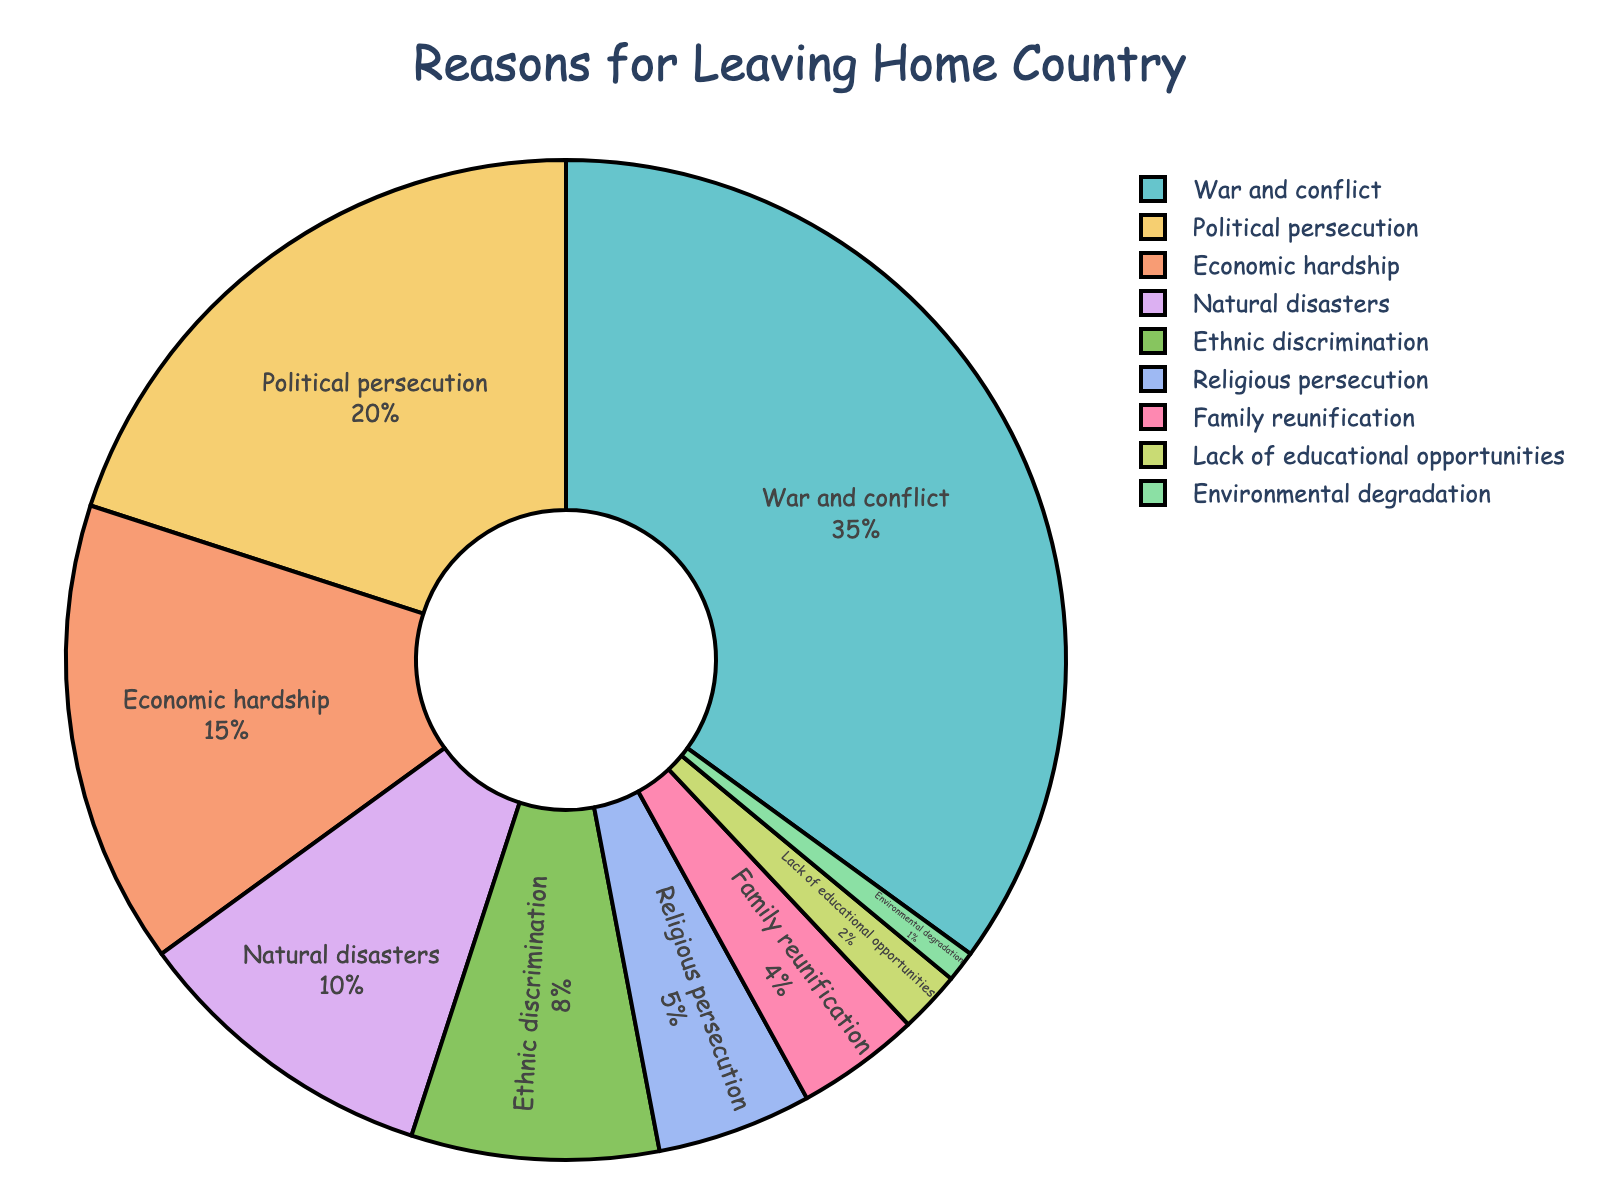What is the most common reason for leaving the home country among refugee families? The largest segment of the pie chart represents the most common reason. The segment labeled 'War and conflict' accounts for 35%.
Answer: War and conflict Which reason is less common, Economic hardship or Religious persecution? Compare the percentages of the respective pie chart segments. Economic hardship is 15%, whereas Religious persecution is 5%.
Answer: Religious persecution What is the combined percentage of refugees leaving due to Political persecution and Ethnic discrimination? Add the percentages represented by the segments labeled 'Political persecution' and 'Ethnic discrimination'. 20% + 8% = 28%.
Answer: 28% Is the percentage of refugees leaving due to Natural disasters greater than, less than, or equal to the percentage leaving due to Lack of educational opportunities? Examine the segments for 'Natural disasters' and 'Lack of educational opportunities'. Natural disasters are 10%, and Lack of educational opportunities is 2%.
Answer: Greater than If you combine the percentages of Family reunification and Environmental degradation, is the total still less than the percentage for Economic hardship? Add the percentages for 'Family reunification' and 'Environmental degradation' and compare with 'Economic hardship'. 4% + 1% = 5%, which is less than 15%.
Answer: Yes Which reason has a percentage closest to the combination of Family reunification and Religious persecution? Adding the percentages for 'Family reunification' and 'Religious persecution' gives 4% + 5% = 9%. The percentage for 'Natural disasters' is closest at 10%.
Answer: Natural disasters How much larger is the percentage for War and conflict compared to Political persecution? Subtract the percentage for Political persecution from War and conflict. 35% - 20% = 15%.
Answer: 15% What percentage of refugees leave due to reasons other than Economic hardship, Political persecution, and War and conflict combined? Subtract the sum of the percentages of 'War and conflict', 'Political persecution', and 'Economic hardship' from 100%. 100% - (35% + 20% + 15%) = 30%.
Answer: 30% Are the percentages of refugees leaving due to War and conflict and Political persecution put together greater than those leaving due to the other reasons combined? Sum the percentages for 'War and conflict' and 'Political persecution' and compare to the sum for all other reasons. (35% + 20%) = 55%, while the rest combined is 45%.
Answer: Yes 